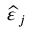Convert formula to latex. <formula><loc_0><loc_0><loc_500><loc_500>{ \widehat { \varepsilon \, } } _ { j }</formula> 